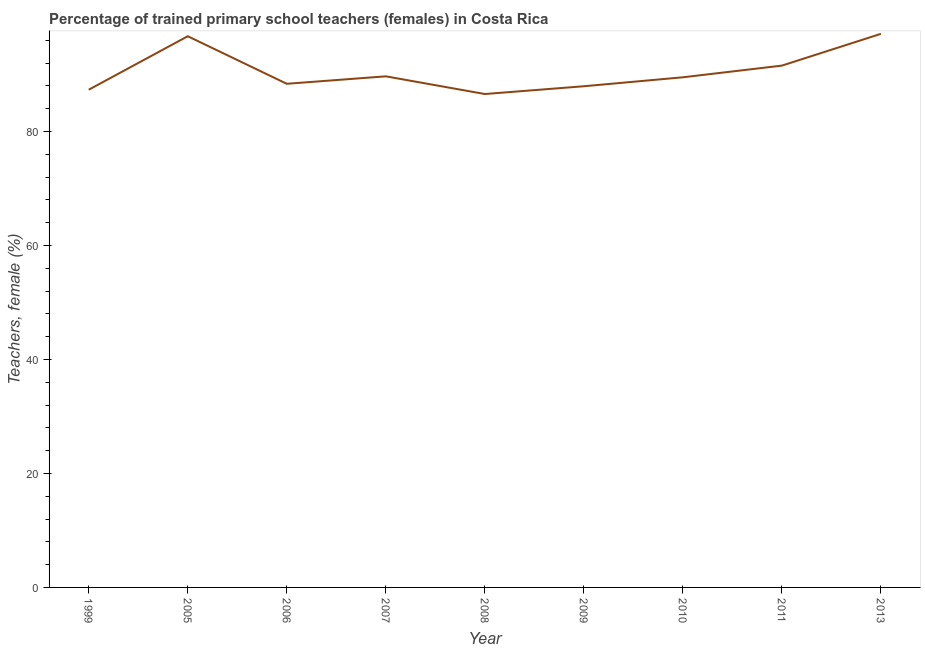What is the percentage of trained female teachers in 2005?
Give a very brief answer. 96.7. Across all years, what is the maximum percentage of trained female teachers?
Offer a terse response. 97.12. Across all years, what is the minimum percentage of trained female teachers?
Make the answer very short. 86.56. In which year was the percentage of trained female teachers maximum?
Ensure brevity in your answer.  2013. What is the sum of the percentage of trained female teachers?
Make the answer very short. 814.7. What is the difference between the percentage of trained female teachers in 2008 and 2010?
Offer a terse response. -2.94. What is the average percentage of trained female teachers per year?
Provide a succinct answer. 90.52. What is the median percentage of trained female teachers?
Give a very brief answer. 89.5. In how many years, is the percentage of trained female teachers greater than 92 %?
Keep it short and to the point. 2. Do a majority of the years between 2013 and 2006 (inclusive) have percentage of trained female teachers greater than 64 %?
Provide a succinct answer. Yes. What is the ratio of the percentage of trained female teachers in 2005 to that in 2008?
Give a very brief answer. 1.12. Is the percentage of trained female teachers in 1999 less than that in 2006?
Keep it short and to the point. Yes. What is the difference between the highest and the second highest percentage of trained female teachers?
Provide a short and direct response. 0.42. Is the sum of the percentage of trained female teachers in 2006 and 2009 greater than the maximum percentage of trained female teachers across all years?
Your answer should be very brief. Yes. What is the difference between the highest and the lowest percentage of trained female teachers?
Offer a very short reply. 10.56. How many lines are there?
Your answer should be compact. 1. Does the graph contain grids?
Your answer should be compact. No. What is the title of the graph?
Offer a terse response. Percentage of trained primary school teachers (females) in Costa Rica. What is the label or title of the X-axis?
Provide a short and direct response. Year. What is the label or title of the Y-axis?
Your answer should be compact. Teachers, female (%). What is the Teachers, female (%) in 1999?
Give a very brief answer. 87.32. What is the Teachers, female (%) in 2005?
Keep it short and to the point. 96.7. What is the Teachers, female (%) of 2006?
Your response must be concise. 88.36. What is the Teachers, female (%) of 2007?
Provide a succinct answer. 89.67. What is the Teachers, female (%) in 2008?
Your response must be concise. 86.56. What is the Teachers, female (%) in 2009?
Provide a succinct answer. 87.93. What is the Teachers, female (%) in 2010?
Provide a succinct answer. 89.5. What is the Teachers, female (%) in 2011?
Provide a succinct answer. 91.54. What is the Teachers, female (%) of 2013?
Provide a short and direct response. 97.12. What is the difference between the Teachers, female (%) in 1999 and 2005?
Offer a terse response. -9.38. What is the difference between the Teachers, female (%) in 1999 and 2006?
Keep it short and to the point. -1.04. What is the difference between the Teachers, female (%) in 1999 and 2007?
Ensure brevity in your answer.  -2.35. What is the difference between the Teachers, female (%) in 1999 and 2008?
Offer a terse response. 0.76. What is the difference between the Teachers, female (%) in 1999 and 2009?
Give a very brief answer. -0.61. What is the difference between the Teachers, female (%) in 1999 and 2010?
Your response must be concise. -2.18. What is the difference between the Teachers, female (%) in 1999 and 2011?
Give a very brief answer. -4.23. What is the difference between the Teachers, female (%) in 1999 and 2013?
Offer a very short reply. -9.8. What is the difference between the Teachers, female (%) in 2005 and 2006?
Your answer should be very brief. 8.34. What is the difference between the Teachers, female (%) in 2005 and 2007?
Keep it short and to the point. 7.04. What is the difference between the Teachers, female (%) in 2005 and 2008?
Provide a short and direct response. 10.14. What is the difference between the Teachers, female (%) in 2005 and 2009?
Offer a very short reply. 8.78. What is the difference between the Teachers, female (%) in 2005 and 2010?
Offer a very short reply. 7.2. What is the difference between the Teachers, female (%) in 2005 and 2011?
Your response must be concise. 5.16. What is the difference between the Teachers, female (%) in 2005 and 2013?
Provide a succinct answer. -0.42. What is the difference between the Teachers, female (%) in 2006 and 2007?
Your answer should be compact. -1.31. What is the difference between the Teachers, female (%) in 2006 and 2008?
Your response must be concise. 1.79. What is the difference between the Teachers, female (%) in 2006 and 2009?
Make the answer very short. 0.43. What is the difference between the Teachers, female (%) in 2006 and 2010?
Your response must be concise. -1.14. What is the difference between the Teachers, female (%) in 2006 and 2011?
Your response must be concise. -3.19. What is the difference between the Teachers, female (%) in 2006 and 2013?
Your answer should be compact. -8.76. What is the difference between the Teachers, female (%) in 2007 and 2008?
Your response must be concise. 3.1. What is the difference between the Teachers, female (%) in 2007 and 2009?
Keep it short and to the point. 1.74. What is the difference between the Teachers, female (%) in 2007 and 2010?
Give a very brief answer. 0.17. What is the difference between the Teachers, female (%) in 2007 and 2011?
Provide a short and direct response. -1.88. What is the difference between the Teachers, female (%) in 2007 and 2013?
Provide a succinct answer. -7.46. What is the difference between the Teachers, female (%) in 2008 and 2009?
Your response must be concise. -1.36. What is the difference between the Teachers, female (%) in 2008 and 2010?
Offer a very short reply. -2.94. What is the difference between the Teachers, female (%) in 2008 and 2011?
Your answer should be compact. -4.98. What is the difference between the Teachers, female (%) in 2008 and 2013?
Make the answer very short. -10.56. What is the difference between the Teachers, female (%) in 2009 and 2010?
Your response must be concise. -1.57. What is the difference between the Teachers, female (%) in 2009 and 2011?
Provide a succinct answer. -3.62. What is the difference between the Teachers, female (%) in 2009 and 2013?
Your response must be concise. -9.2. What is the difference between the Teachers, female (%) in 2010 and 2011?
Your response must be concise. -2.05. What is the difference between the Teachers, female (%) in 2010 and 2013?
Offer a terse response. -7.62. What is the difference between the Teachers, female (%) in 2011 and 2013?
Provide a succinct answer. -5.58. What is the ratio of the Teachers, female (%) in 1999 to that in 2005?
Keep it short and to the point. 0.9. What is the ratio of the Teachers, female (%) in 1999 to that in 2006?
Your response must be concise. 0.99. What is the ratio of the Teachers, female (%) in 1999 to that in 2009?
Provide a short and direct response. 0.99. What is the ratio of the Teachers, female (%) in 1999 to that in 2010?
Offer a terse response. 0.98. What is the ratio of the Teachers, female (%) in 1999 to that in 2011?
Provide a succinct answer. 0.95. What is the ratio of the Teachers, female (%) in 1999 to that in 2013?
Offer a terse response. 0.9. What is the ratio of the Teachers, female (%) in 2005 to that in 2006?
Give a very brief answer. 1.09. What is the ratio of the Teachers, female (%) in 2005 to that in 2007?
Give a very brief answer. 1.08. What is the ratio of the Teachers, female (%) in 2005 to that in 2008?
Keep it short and to the point. 1.12. What is the ratio of the Teachers, female (%) in 2005 to that in 2010?
Offer a very short reply. 1.08. What is the ratio of the Teachers, female (%) in 2005 to that in 2011?
Provide a short and direct response. 1.06. What is the ratio of the Teachers, female (%) in 2005 to that in 2013?
Ensure brevity in your answer.  1. What is the ratio of the Teachers, female (%) in 2006 to that in 2007?
Keep it short and to the point. 0.98. What is the ratio of the Teachers, female (%) in 2006 to that in 2008?
Your answer should be compact. 1.02. What is the ratio of the Teachers, female (%) in 2006 to that in 2009?
Make the answer very short. 1. What is the ratio of the Teachers, female (%) in 2006 to that in 2011?
Make the answer very short. 0.96. What is the ratio of the Teachers, female (%) in 2006 to that in 2013?
Your answer should be very brief. 0.91. What is the ratio of the Teachers, female (%) in 2007 to that in 2008?
Your response must be concise. 1.04. What is the ratio of the Teachers, female (%) in 2007 to that in 2010?
Offer a very short reply. 1. What is the ratio of the Teachers, female (%) in 2007 to that in 2013?
Your answer should be very brief. 0.92. What is the ratio of the Teachers, female (%) in 2008 to that in 2009?
Provide a short and direct response. 0.98. What is the ratio of the Teachers, female (%) in 2008 to that in 2010?
Your answer should be compact. 0.97. What is the ratio of the Teachers, female (%) in 2008 to that in 2011?
Offer a very short reply. 0.95. What is the ratio of the Teachers, female (%) in 2008 to that in 2013?
Your response must be concise. 0.89. What is the ratio of the Teachers, female (%) in 2009 to that in 2010?
Offer a terse response. 0.98. What is the ratio of the Teachers, female (%) in 2009 to that in 2013?
Give a very brief answer. 0.91. What is the ratio of the Teachers, female (%) in 2010 to that in 2011?
Ensure brevity in your answer.  0.98. What is the ratio of the Teachers, female (%) in 2010 to that in 2013?
Your answer should be compact. 0.92. What is the ratio of the Teachers, female (%) in 2011 to that in 2013?
Provide a short and direct response. 0.94. 